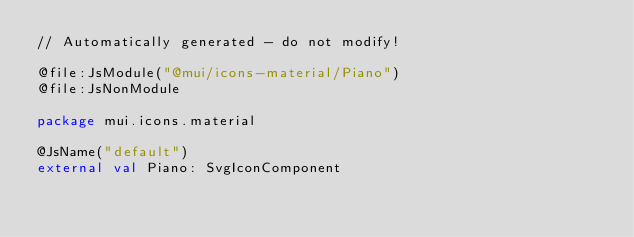<code> <loc_0><loc_0><loc_500><loc_500><_Kotlin_>// Automatically generated - do not modify!

@file:JsModule("@mui/icons-material/Piano")
@file:JsNonModule

package mui.icons.material

@JsName("default")
external val Piano: SvgIconComponent
</code> 